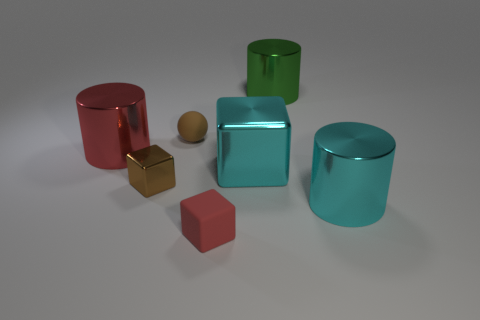Add 3 tiny shiny cubes. How many objects exist? 10 Subtract all cubes. How many objects are left? 4 Subtract all small yellow metallic objects. Subtract all large red cylinders. How many objects are left? 6 Add 2 large green metal objects. How many large green metal objects are left? 3 Add 1 big cyan blocks. How many big cyan blocks exist? 2 Subtract 1 brown cubes. How many objects are left? 6 